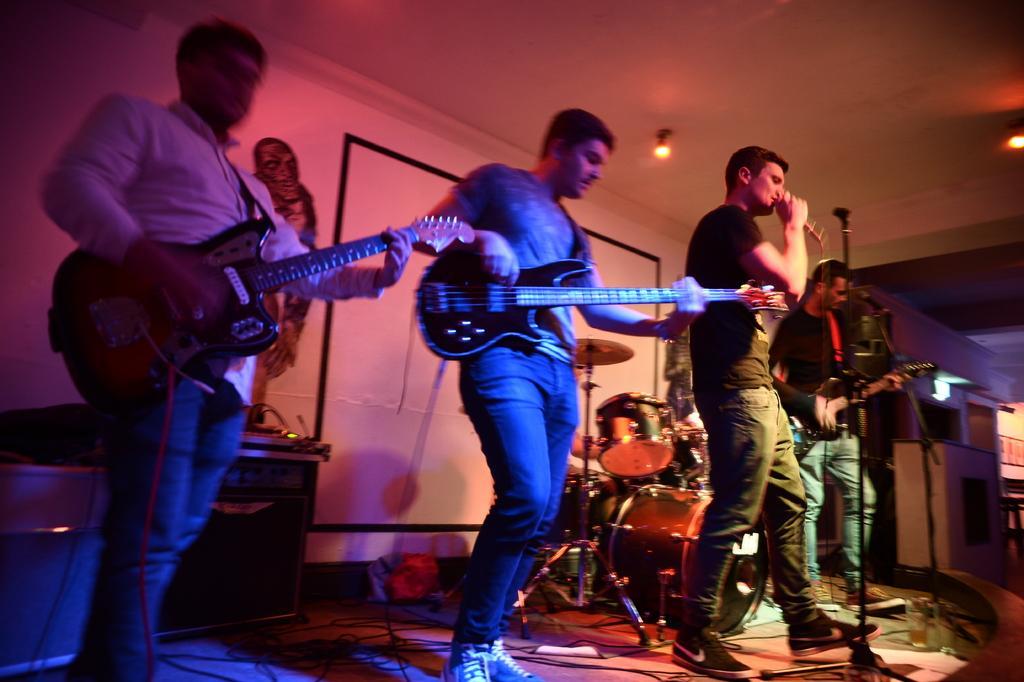How would you summarize this image in a sentence or two? In this image, we can see few people are standing on the stage. Few are holding musical instruments. Here a person is holding a microphone. Background we can see some boxes, musical instrument, screen, wall, sticker, few objects. Top of the image, there is a ceiling with lights. 